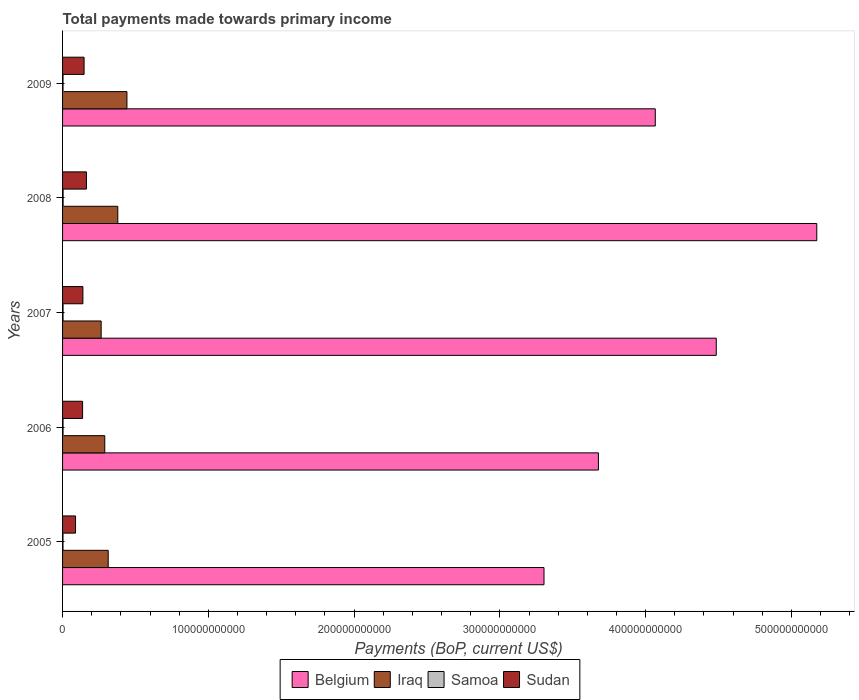What is the total payments made towards primary income in Sudan in 2008?
Offer a very short reply. 1.64e+1. Across all years, what is the maximum total payments made towards primary income in Samoa?
Ensure brevity in your answer.  3.77e+08. Across all years, what is the minimum total payments made towards primary income in Samoa?
Provide a short and direct response. 3.00e+08. In which year was the total payments made towards primary income in Belgium maximum?
Provide a short and direct response. 2008. In which year was the total payments made towards primary income in Iraq minimum?
Provide a short and direct response. 2007. What is the total total payments made towards primary income in Iraq in the graph?
Give a very brief answer. 1.69e+11. What is the difference between the total payments made towards primary income in Samoa in 2005 and that in 2008?
Offer a terse response. -7.67e+07. What is the difference between the total payments made towards primary income in Sudan in 2009 and the total payments made towards primary income in Belgium in 2008?
Your answer should be very brief. -5.03e+11. What is the average total payments made towards primary income in Iraq per year?
Provide a succinct answer. 3.38e+1. In the year 2009, what is the difference between the total payments made towards primary income in Sudan and total payments made towards primary income in Belgium?
Your answer should be compact. -3.92e+11. What is the ratio of the total payments made towards primary income in Sudan in 2005 to that in 2007?
Make the answer very short. 0.64. What is the difference between the highest and the second highest total payments made towards primary income in Belgium?
Provide a short and direct response. 6.90e+1. What is the difference between the highest and the lowest total payments made towards primary income in Samoa?
Your answer should be very brief. 7.67e+07. Is the sum of the total payments made towards primary income in Samoa in 2007 and 2008 greater than the maximum total payments made towards primary income in Iraq across all years?
Keep it short and to the point. No. Is it the case that in every year, the sum of the total payments made towards primary income in Sudan and total payments made towards primary income in Belgium is greater than the sum of total payments made towards primary income in Samoa and total payments made towards primary income in Iraq?
Offer a terse response. No. What does the 1st bar from the top in 2007 represents?
Ensure brevity in your answer.  Sudan. What does the 3rd bar from the bottom in 2008 represents?
Your answer should be compact. Samoa. How many bars are there?
Offer a very short reply. 20. How many years are there in the graph?
Your answer should be compact. 5. What is the difference between two consecutive major ticks on the X-axis?
Ensure brevity in your answer.  1.00e+11. Does the graph contain grids?
Your response must be concise. No. Where does the legend appear in the graph?
Give a very brief answer. Bottom center. How many legend labels are there?
Offer a terse response. 4. How are the legend labels stacked?
Your answer should be compact. Horizontal. What is the title of the graph?
Offer a very short reply. Total payments made towards primary income. What is the label or title of the X-axis?
Provide a succinct answer. Payments (BoP, current US$). What is the label or title of the Y-axis?
Provide a short and direct response. Years. What is the Payments (BoP, current US$) in Belgium in 2005?
Ensure brevity in your answer.  3.30e+11. What is the Payments (BoP, current US$) in Iraq in 2005?
Offer a terse response. 3.13e+1. What is the Payments (BoP, current US$) in Samoa in 2005?
Your answer should be very brief. 3.00e+08. What is the Payments (BoP, current US$) of Sudan in 2005?
Provide a short and direct response. 8.90e+09. What is the Payments (BoP, current US$) of Belgium in 2006?
Provide a short and direct response. 3.68e+11. What is the Payments (BoP, current US$) of Iraq in 2006?
Your answer should be compact. 2.89e+1. What is the Payments (BoP, current US$) in Samoa in 2006?
Provide a short and direct response. 3.29e+08. What is the Payments (BoP, current US$) in Sudan in 2006?
Keep it short and to the point. 1.37e+1. What is the Payments (BoP, current US$) in Belgium in 2007?
Make the answer very short. 4.48e+11. What is the Payments (BoP, current US$) in Iraq in 2007?
Provide a succinct answer. 2.65e+1. What is the Payments (BoP, current US$) in Samoa in 2007?
Your answer should be compact. 3.44e+08. What is the Payments (BoP, current US$) of Sudan in 2007?
Your answer should be compact. 1.40e+1. What is the Payments (BoP, current US$) of Belgium in 2008?
Your response must be concise. 5.17e+11. What is the Payments (BoP, current US$) in Iraq in 2008?
Your response must be concise. 3.79e+1. What is the Payments (BoP, current US$) in Samoa in 2008?
Your answer should be compact. 3.77e+08. What is the Payments (BoP, current US$) in Sudan in 2008?
Give a very brief answer. 1.64e+1. What is the Payments (BoP, current US$) of Belgium in 2009?
Your response must be concise. 4.07e+11. What is the Payments (BoP, current US$) of Iraq in 2009?
Offer a terse response. 4.42e+1. What is the Payments (BoP, current US$) of Samoa in 2009?
Your answer should be very brief. 3.20e+08. What is the Payments (BoP, current US$) in Sudan in 2009?
Make the answer very short. 1.48e+1. Across all years, what is the maximum Payments (BoP, current US$) in Belgium?
Ensure brevity in your answer.  5.17e+11. Across all years, what is the maximum Payments (BoP, current US$) in Iraq?
Provide a succinct answer. 4.42e+1. Across all years, what is the maximum Payments (BoP, current US$) of Samoa?
Your response must be concise. 3.77e+08. Across all years, what is the maximum Payments (BoP, current US$) in Sudan?
Provide a short and direct response. 1.64e+1. Across all years, what is the minimum Payments (BoP, current US$) of Belgium?
Provide a succinct answer. 3.30e+11. Across all years, what is the minimum Payments (BoP, current US$) of Iraq?
Your answer should be compact. 2.65e+1. Across all years, what is the minimum Payments (BoP, current US$) of Samoa?
Offer a terse response. 3.00e+08. Across all years, what is the minimum Payments (BoP, current US$) in Sudan?
Offer a very short reply. 8.90e+09. What is the total Payments (BoP, current US$) of Belgium in the graph?
Your answer should be compact. 2.07e+12. What is the total Payments (BoP, current US$) in Iraq in the graph?
Offer a terse response. 1.69e+11. What is the total Payments (BoP, current US$) of Samoa in the graph?
Provide a succinct answer. 1.67e+09. What is the total Payments (BoP, current US$) in Sudan in the graph?
Your answer should be very brief. 6.77e+1. What is the difference between the Payments (BoP, current US$) in Belgium in 2005 and that in 2006?
Offer a very short reply. -3.73e+1. What is the difference between the Payments (BoP, current US$) in Iraq in 2005 and that in 2006?
Provide a succinct answer. 2.36e+09. What is the difference between the Payments (BoP, current US$) of Samoa in 2005 and that in 2006?
Your response must be concise. -2.86e+07. What is the difference between the Payments (BoP, current US$) of Sudan in 2005 and that in 2006?
Ensure brevity in your answer.  -4.84e+09. What is the difference between the Payments (BoP, current US$) of Belgium in 2005 and that in 2007?
Provide a succinct answer. -1.18e+11. What is the difference between the Payments (BoP, current US$) of Iraq in 2005 and that in 2007?
Provide a succinct answer. 4.83e+09. What is the difference between the Payments (BoP, current US$) of Samoa in 2005 and that in 2007?
Offer a very short reply. -4.42e+07. What is the difference between the Payments (BoP, current US$) of Sudan in 2005 and that in 2007?
Ensure brevity in your answer.  -5.05e+09. What is the difference between the Payments (BoP, current US$) in Belgium in 2005 and that in 2008?
Offer a terse response. -1.87e+11. What is the difference between the Payments (BoP, current US$) in Iraq in 2005 and that in 2008?
Offer a terse response. -6.58e+09. What is the difference between the Payments (BoP, current US$) in Samoa in 2005 and that in 2008?
Ensure brevity in your answer.  -7.67e+07. What is the difference between the Payments (BoP, current US$) in Sudan in 2005 and that in 2008?
Your answer should be very brief. -7.49e+09. What is the difference between the Payments (BoP, current US$) of Belgium in 2005 and that in 2009?
Keep it short and to the point. -7.63e+1. What is the difference between the Payments (BoP, current US$) of Iraq in 2005 and that in 2009?
Make the answer very short. -1.29e+1. What is the difference between the Payments (BoP, current US$) of Samoa in 2005 and that in 2009?
Offer a very short reply. -1.96e+07. What is the difference between the Payments (BoP, current US$) of Sudan in 2005 and that in 2009?
Provide a succinct answer. -5.86e+09. What is the difference between the Payments (BoP, current US$) of Belgium in 2006 and that in 2007?
Offer a terse response. -8.08e+1. What is the difference between the Payments (BoP, current US$) in Iraq in 2006 and that in 2007?
Provide a succinct answer. 2.47e+09. What is the difference between the Payments (BoP, current US$) of Samoa in 2006 and that in 2007?
Your answer should be compact. -1.56e+07. What is the difference between the Payments (BoP, current US$) of Sudan in 2006 and that in 2007?
Provide a short and direct response. -2.10e+08. What is the difference between the Payments (BoP, current US$) of Belgium in 2006 and that in 2008?
Keep it short and to the point. -1.50e+11. What is the difference between the Payments (BoP, current US$) in Iraq in 2006 and that in 2008?
Offer a very short reply. -8.94e+09. What is the difference between the Payments (BoP, current US$) in Samoa in 2006 and that in 2008?
Give a very brief answer. -4.81e+07. What is the difference between the Payments (BoP, current US$) in Sudan in 2006 and that in 2008?
Provide a succinct answer. -2.64e+09. What is the difference between the Payments (BoP, current US$) of Belgium in 2006 and that in 2009?
Ensure brevity in your answer.  -3.90e+1. What is the difference between the Payments (BoP, current US$) in Iraq in 2006 and that in 2009?
Ensure brevity in your answer.  -1.52e+1. What is the difference between the Payments (BoP, current US$) of Samoa in 2006 and that in 2009?
Your answer should be compact. 8.97e+06. What is the difference between the Payments (BoP, current US$) in Sudan in 2006 and that in 2009?
Give a very brief answer. -1.02e+09. What is the difference between the Payments (BoP, current US$) of Belgium in 2007 and that in 2008?
Keep it short and to the point. -6.90e+1. What is the difference between the Payments (BoP, current US$) in Iraq in 2007 and that in 2008?
Give a very brief answer. -1.14e+1. What is the difference between the Payments (BoP, current US$) in Samoa in 2007 and that in 2008?
Ensure brevity in your answer.  -3.25e+07. What is the difference between the Payments (BoP, current US$) of Sudan in 2007 and that in 2008?
Offer a terse response. -2.43e+09. What is the difference between the Payments (BoP, current US$) of Belgium in 2007 and that in 2009?
Offer a terse response. 4.18e+1. What is the difference between the Payments (BoP, current US$) of Iraq in 2007 and that in 2009?
Provide a succinct answer. -1.77e+1. What is the difference between the Payments (BoP, current US$) in Samoa in 2007 and that in 2009?
Your response must be concise. 2.46e+07. What is the difference between the Payments (BoP, current US$) in Sudan in 2007 and that in 2009?
Offer a very short reply. -8.09e+08. What is the difference between the Payments (BoP, current US$) of Belgium in 2008 and that in 2009?
Your answer should be very brief. 1.11e+11. What is the difference between the Payments (BoP, current US$) of Iraq in 2008 and that in 2009?
Make the answer very short. -6.28e+09. What is the difference between the Payments (BoP, current US$) of Samoa in 2008 and that in 2009?
Your answer should be compact. 5.70e+07. What is the difference between the Payments (BoP, current US$) of Sudan in 2008 and that in 2009?
Your response must be concise. 1.62e+09. What is the difference between the Payments (BoP, current US$) in Belgium in 2005 and the Payments (BoP, current US$) in Iraq in 2006?
Your response must be concise. 3.01e+11. What is the difference between the Payments (BoP, current US$) of Belgium in 2005 and the Payments (BoP, current US$) of Samoa in 2006?
Your response must be concise. 3.30e+11. What is the difference between the Payments (BoP, current US$) in Belgium in 2005 and the Payments (BoP, current US$) in Sudan in 2006?
Your answer should be very brief. 3.17e+11. What is the difference between the Payments (BoP, current US$) of Iraq in 2005 and the Payments (BoP, current US$) of Samoa in 2006?
Your answer should be compact. 3.10e+1. What is the difference between the Payments (BoP, current US$) of Iraq in 2005 and the Payments (BoP, current US$) of Sudan in 2006?
Offer a terse response. 1.76e+1. What is the difference between the Payments (BoP, current US$) in Samoa in 2005 and the Payments (BoP, current US$) in Sudan in 2006?
Ensure brevity in your answer.  -1.34e+1. What is the difference between the Payments (BoP, current US$) of Belgium in 2005 and the Payments (BoP, current US$) of Iraq in 2007?
Ensure brevity in your answer.  3.04e+11. What is the difference between the Payments (BoP, current US$) of Belgium in 2005 and the Payments (BoP, current US$) of Samoa in 2007?
Provide a short and direct response. 3.30e+11. What is the difference between the Payments (BoP, current US$) in Belgium in 2005 and the Payments (BoP, current US$) in Sudan in 2007?
Your answer should be very brief. 3.16e+11. What is the difference between the Payments (BoP, current US$) of Iraq in 2005 and the Payments (BoP, current US$) of Samoa in 2007?
Make the answer very short. 3.10e+1. What is the difference between the Payments (BoP, current US$) in Iraq in 2005 and the Payments (BoP, current US$) in Sudan in 2007?
Offer a terse response. 1.74e+1. What is the difference between the Payments (BoP, current US$) of Samoa in 2005 and the Payments (BoP, current US$) of Sudan in 2007?
Ensure brevity in your answer.  -1.37e+1. What is the difference between the Payments (BoP, current US$) of Belgium in 2005 and the Payments (BoP, current US$) of Iraq in 2008?
Provide a succinct answer. 2.92e+11. What is the difference between the Payments (BoP, current US$) in Belgium in 2005 and the Payments (BoP, current US$) in Samoa in 2008?
Your response must be concise. 3.30e+11. What is the difference between the Payments (BoP, current US$) of Belgium in 2005 and the Payments (BoP, current US$) of Sudan in 2008?
Make the answer very short. 3.14e+11. What is the difference between the Payments (BoP, current US$) in Iraq in 2005 and the Payments (BoP, current US$) in Samoa in 2008?
Offer a very short reply. 3.09e+1. What is the difference between the Payments (BoP, current US$) in Iraq in 2005 and the Payments (BoP, current US$) in Sudan in 2008?
Your answer should be very brief. 1.49e+1. What is the difference between the Payments (BoP, current US$) in Samoa in 2005 and the Payments (BoP, current US$) in Sudan in 2008?
Keep it short and to the point. -1.61e+1. What is the difference between the Payments (BoP, current US$) of Belgium in 2005 and the Payments (BoP, current US$) of Iraq in 2009?
Provide a succinct answer. 2.86e+11. What is the difference between the Payments (BoP, current US$) of Belgium in 2005 and the Payments (BoP, current US$) of Samoa in 2009?
Your answer should be very brief. 3.30e+11. What is the difference between the Payments (BoP, current US$) in Belgium in 2005 and the Payments (BoP, current US$) in Sudan in 2009?
Ensure brevity in your answer.  3.16e+11. What is the difference between the Payments (BoP, current US$) of Iraq in 2005 and the Payments (BoP, current US$) of Samoa in 2009?
Your answer should be very brief. 3.10e+1. What is the difference between the Payments (BoP, current US$) of Iraq in 2005 and the Payments (BoP, current US$) of Sudan in 2009?
Your answer should be very brief. 1.65e+1. What is the difference between the Payments (BoP, current US$) in Samoa in 2005 and the Payments (BoP, current US$) in Sudan in 2009?
Your answer should be very brief. -1.45e+1. What is the difference between the Payments (BoP, current US$) of Belgium in 2006 and the Payments (BoP, current US$) of Iraq in 2007?
Offer a terse response. 3.41e+11. What is the difference between the Payments (BoP, current US$) of Belgium in 2006 and the Payments (BoP, current US$) of Samoa in 2007?
Offer a very short reply. 3.67e+11. What is the difference between the Payments (BoP, current US$) of Belgium in 2006 and the Payments (BoP, current US$) of Sudan in 2007?
Offer a very short reply. 3.54e+11. What is the difference between the Payments (BoP, current US$) of Iraq in 2006 and the Payments (BoP, current US$) of Samoa in 2007?
Provide a short and direct response. 2.86e+1. What is the difference between the Payments (BoP, current US$) in Iraq in 2006 and the Payments (BoP, current US$) in Sudan in 2007?
Give a very brief answer. 1.50e+1. What is the difference between the Payments (BoP, current US$) in Samoa in 2006 and the Payments (BoP, current US$) in Sudan in 2007?
Provide a short and direct response. -1.36e+1. What is the difference between the Payments (BoP, current US$) in Belgium in 2006 and the Payments (BoP, current US$) in Iraq in 2008?
Provide a succinct answer. 3.30e+11. What is the difference between the Payments (BoP, current US$) of Belgium in 2006 and the Payments (BoP, current US$) of Samoa in 2008?
Provide a succinct answer. 3.67e+11. What is the difference between the Payments (BoP, current US$) in Belgium in 2006 and the Payments (BoP, current US$) in Sudan in 2008?
Give a very brief answer. 3.51e+11. What is the difference between the Payments (BoP, current US$) of Iraq in 2006 and the Payments (BoP, current US$) of Samoa in 2008?
Provide a succinct answer. 2.86e+1. What is the difference between the Payments (BoP, current US$) in Iraq in 2006 and the Payments (BoP, current US$) in Sudan in 2008?
Make the answer very short. 1.26e+1. What is the difference between the Payments (BoP, current US$) of Samoa in 2006 and the Payments (BoP, current US$) of Sudan in 2008?
Keep it short and to the point. -1.61e+1. What is the difference between the Payments (BoP, current US$) of Belgium in 2006 and the Payments (BoP, current US$) of Iraq in 2009?
Make the answer very short. 3.23e+11. What is the difference between the Payments (BoP, current US$) of Belgium in 2006 and the Payments (BoP, current US$) of Samoa in 2009?
Make the answer very short. 3.67e+11. What is the difference between the Payments (BoP, current US$) of Belgium in 2006 and the Payments (BoP, current US$) of Sudan in 2009?
Provide a succinct answer. 3.53e+11. What is the difference between the Payments (BoP, current US$) of Iraq in 2006 and the Payments (BoP, current US$) of Samoa in 2009?
Your response must be concise. 2.86e+1. What is the difference between the Payments (BoP, current US$) in Iraq in 2006 and the Payments (BoP, current US$) in Sudan in 2009?
Make the answer very short. 1.42e+1. What is the difference between the Payments (BoP, current US$) of Samoa in 2006 and the Payments (BoP, current US$) of Sudan in 2009?
Make the answer very short. -1.44e+1. What is the difference between the Payments (BoP, current US$) in Belgium in 2007 and the Payments (BoP, current US$) in Iraq in 2008?
Offer a very short reply. 4.11e+11. What is the difference between the Payments (BoP, current US$) in Belgium in 2007 and the Payments (BoP, current US$) in Samoa in 2008?
Provide a succinct answer. 4.48e+11. What is the difference between the Payments (BoP, current US$) of Belgium in 2007 and the Payments (BoP, current US$) of Sudan in 2008?
Provide a short and direct response. 4.32e+11. What is the difference between the Payments (BoP, current US$) in Iraq in 2007 and the Payments (BoP, current US$) in Samoa in 2008?
Keep it short and to the point. 2.61e+1. What is the difference between the Payments (BoP, current US$) of Iraq in 2007 and the Payments (BoP, current US$) of Sudan in 2008?
Your answer should be very brief. 1.01e+1. What is the difference between the Payments (BoP, current US$) of Samoa in 2007 and the Payments (BoP, current US$) of Sudan in 2008?
Your answer should be very brief. -1.60e+1. What is the difference between the Payments (BoP, current US$) of Belgium in 2007 and the Payments (BoP, current US$) of Iraq in 2009?
Your answer should be compact. 4.04e+11. What is the difference between the Payments (BoP, current US$) in Belgium in 2007 and the Payments (BoP, current US$) in Samoa in 2009?
Provide a succinct answer. 4.48e+11. What is the difference between the Payments (BoP, current US$) of Belgium in 2007 and the Payments (BoP, current US$) of Sudan in 2009?
Provide a short and direct response. 4.34e+11. What is the difference between the Payments (BoP, current US$) of Iraq in 2007 and the Payments (BoP, current US$) of Samoa in 2009?
Provide a short and direct response. 2.62e+1. What is the difference between the Payments (BoP, current US$) in Iraq in 2007 and the Payments (BoP, current US$) in Sudan in 2009?
Ensure brevity in your answer.  1.17e+1. What is the difference between the Payments (BoP, current US$) of Samoa in 2007 and the Payments (BoP, current US$) of Sudan in 2009?
Your response must be concise. -1.44e+1. What is the difference between the Payments (BoP, current US$) of Belgium in 2008 and the Payments (BoP, current US$) of Iraq in 2009?
Keep it short and to the point. 4.73e+11. What is the difference between the Payments (BoP, current US$) of Belgium in 2008 and the Payments (BoP, current US$) of Samoa in 2009?
Your answer should be very brief. 5.17e+11. What is the difference between the Payments (BoP, current US$) in Belgium in 2008 and the Payments (BoP, current US$) in Sudan in 2009?
Offer a very short reply. 5.03e+11. What is the difference between the Payments (BoP, current US$) in Iraq in 2008 and the Payments (BoP, current US$) in Samoa in 2009?
Your response must be concise. 3.76e+1. What is the difference between the Payments (BoP, current US$) of Iraq in 2008 and the Payments (BoP, current US$) of Sudan in 2009?
Offer a very short reply. 2.31e+1. What is the difference between the Payments (BoP, current US$) of Samoa in 2008 and the Payments (BoP, current US$) of Sudan in 2009?
Keep it short and to the point. -1.44e+1. What is the average Payments (BoP, current US$) in Belgium per year?
Offer a very short reply. 4.14e+11. What is the average Payments (BoP, current US$) of Iraq per year?
Your answer should be very brief. 3.38e+1. What is the average Payments (BoP, current US$) of Samoa per year?
Provide a short and direct response. 3.34e+08. What is the average Payments (BoP, current US$) in Sudan per year?
Keep it short and to the point. 1.35e+1. In the year 2005, what is the difference between the Payments (BoP, current US$) in Belgium and Payments (BoP, current US$) in Iraq?
Your response must be concise. 2.99e+11. In the year 2005, what is the difference between the Payments (BoP, current US$) of Belgium and Payments (BoP, current US$) of Samoa?
Make the answer very short. 3.30e+11. In the year 2005, what is the difference between the Payments (BoP, current US$) in Belgium and Payments (BoP, current US$) in Sudan?
Provide a short and direct response. 3.21e+11. In the year 2005, what is the difference between the Payments (BoP, current US$) of Iraq and Payments (BoP, current US$) of Samoa?
Make the answer very short. 3.10e+1. In the year 2005, what is the difference between the Payments (BoP, current US$) in Iraq and Payments (BoP, current US$) in Sudan?
Provide a short and direct response. 2.24e+1. In the year 2005, what is the difference between the Payments (BoP, current US$) in Samoa and Payments (BoP, current US$) in Sudan?
Offer a very short reply. -8.60e+09. In the year 2006, what is the difference between the Payments (BoP, current US$) of Belgium and Payments (BoP, current US$) of Iraq?
Keep it short and to the point. 3.39e+11. In the year 2006, what is the difference between the Payments (BoP, current US$) in Belgium and Payments (BoP, current US$) in Samoa?
Your response must be concise. 3.67e+11. In the year 2006, what is the difference between the Payments (BoP, current US$) of Belgium and Payments (BoP, current US$) of Sudan?
Your answer should be compact. 3.54e+11. In the year 2006, what is the difference between the Payments (BoP, current US$) of Iraq and Payments (BoP, current US$) of Samoa?
Ensure brevity in your answer.  2.86e+1. In the year 2006, what is the difference between the Payments (BoP, current US$) in Iraq and Payments (BoP, current US$) in Sudan?
Offer a terse response. 1.52e+1. In the year 2006, what is the difference between the Payments (BoP, current US$) of Samoa and Payments (BoP, current US$) of Sudan?
Provide a short and direct response. -1.34e+1. In the year 2007, what is the difference between the Payments (BoP, current US$) of Belgium and Payments (BoP, current US$) of Iraq?
Give a very brief answer. 4.22e+11. In the year 2007, what is the difference between the Payments (BoP, current US$) in Belgium and Payments (BoP, current US$) in Samoa?
Provide a succinct answer. 4.48e+11. In the year 2007, what is the difference between the Payments (BoP, current US$) in Belgium and Payments (BoP, current US$) in Sudan?
Your answer should be very brief. 4.35e+11. In the year 2007, what is the difference between the Payments (BoP, current US$) in Iraq and Payments (BoP, current US$) in Samoa?
Provide a short and direct response. 2.61e+1. In the year 2007, what is the difference between the Payments (BoP, current US$) of Iraq and Payments (BoP, current US$) of Sudan?
Provide a succinct answer. 1.25e+1. In the year 2007, what is the difference between the Payments (BoP, current US$) of Samoa and Payments (BoP, current US$) of Sudan?
Offer a terse response. -1.36e+1. In the year 2008, what is the difference between the Payments (BoP, current US$) in Belgium and Payments (BoP, current US$) in Iraq?
Your answer should be very brief. 4.80e+11. In the year 2008, what is the difference between the Payments (BoP, current US$) in Belgium and Payments (BoP, current US$) in Samoa?
Ensure brevity in your answer.  5.17e+11. In the year 2008, what is the difference between the Payments (BoP, current US$) of Belgium and Payments (BoP, current US$) of Sudan?
Your answer should be compact. 5.01e+11. In the year 2008, what is the difference between the Payments (BoP, current US$) of Iraq and Payments (BoP, current US$) of Samoa?
Your response must be concise. 3.75e+1. In the year 2008, what is the difference between the Payments (BoP, current US$) in Iraq and Payments (BoP, current US$) in Sudan?
Offer a terse response. 2.15e+1. In the year 2008, what is the difference between the Payments (BoP, current US$) in Samoa and Payments (BoP, current US$) in Sudan?
Keep it short and to the point. -1.60e+1. In the year 2009, what is the difference between the Payments (BoP, current US$) of Belgium and Payments (BoP, current US$) of Iraq?
Give a very brief answer. 3.62e+11. In the year 2009, what is the difference between the Payments (BoP, current US$) of Belgium and Payments (BoP, current US$) of Samoa?
Provide a short and direct response. 4.06e+11. In the year 2009, what is the difference between the Payments (BoP, current US$) of Belgium and Payments (BoP, current US$) of Sudan?
Your answer should be compact. 3.92e+11. In the year 2009, what is the difference between the Payments (BoP, current US$) of Iraq and Payments (BoP, current US$) of Samoa?
Provide a succinct answer. 4.38e+1. In the year 2009, what is the difference between the Payments (BoP, current US$) of Iraq and Payments (BoP, current US$) of Sudan?
Offer a terse response. 2.94e+1. In the year 2009, what is the difference between the Payments (BoP, current US$) in Samoa and Payments (BoP, current US$) in Sudan?
Make the answer very short. -1.44e+1. What is the ratio of the Payments (BoP, current US$) in Belgium in 2005 to that in 2006?
Keep it short and to the point. 0.9. What is the ratio of the Payments (BoP, current US$) in Iraq in 2005 to that in 2006?
Ensure brevity in your answer.  1.08. What is the ratio of the Payments (BoP, current US$) of Samoa in 2005 to that in 2006?
Keep it short and to the point. 0.91. What is the ratio of the Payments (BoP, current US$) of Sudan in 2005 to that in 2006?
Your answer should be very brief. 0.65. What is the ratio of the Payments (BoP, current US$) in Belgium in 2005 to that in 2007?
Make the answer very short. 0.74. What is the ratio of the Payments (BoP, current US$) in Iraq in 2005 to that in 2007?
Ensure brevity in your answer.  1.18. What is the ratio of the Payments (BoP, current US$) in Samoa in 2005 to that in 2007?
Give a very brief answer. 0.87. What is the ratio of the Payments (BoP, current US$) of Sudan in 2005 to that in 2007?
Your answer should be compact. 0.64. What is the ratio of the Payments (BoP, current US$) of Belgium in 2005 to that in 2008?
Your response must be concise. 0.64. What is the ratio of the Payments (BoP, current US$) of Iraq in 2005 to that in 2008?
Keep it short and to the point. 0.83. What is the ratio of the Payments (BoP, current US$) in Samoa in 2005 to that in 2008?
Your answer should be very brief. 0.8. What is the ratio of the Payments (BoP, current US$) of Sudan in 2005 to that in 2008?
Provide a short and direct response. 0.54. What is the ratio of the Payments (BoP, current US$) in Belgium in 2005 to that in 2009?
Give a very brief answer. 0.81. What is the ratio of the Payments (BoP, current US$) of Iraq in 2005 to that in 2009?
Keep it short and to the point. 0.71. What is the ratio of the Payments (BoP, current US$) in Samoa in 2005 to that in 2009?
Your answer should be compact. 0.94. What is the ratio of the Payments (BoP, current US$) of Sudan in 2005 to that in 2009?
Provide a succinct answer. 0.6. What is the ratio of the Payments (BoP, current US$) in Belgium in 2006 to that in 2007?
Ensure brevity in your answer.  0.82. What is the ratio of the Payments (BoP, current US$) in Iraq in 2006 to that in 2007?
Provide a short and direct response. 1.09. What is the ratio of the Payments (BoP, current US$) of Samoa in 2006 to that in 2007?
Make the answer very short. 0.95. What is the ratio of the Payments (BoP, current US$) of Sudan in 2006 to that in 2007?
Ensure brevity in your answer.  0.98. What is the ratio of the Payments (BoP, current US$) of Belgium in 2006 to that in 2008?
Provide a succinct answer. 0.71. What is the ratio of the Payments (BoP, current US$) in Iraq in 2006 to that in 2008?
Provide a succinct answer. 0.76. What is the ratio of the Payments (BoP, current US$) in Samoa in 2006 to that in 2008?
Provide a short and direct response. 0.87. What is the ratio of the Payments (BoP, current US$) in Sudan in 2006 to that in 2008?
Offer a terse response. 0.84. What is the ratio of the Payments (BoP, current US$) of Belgium in 2006 to that in 2009?
Your answer should be very brief. 0.9. What is the ratio of the Payments (BoP, current US$) of Iraq in 2006 to that in 2009?
Provide a succinct answer. 0.66. What is the ratio of the Payments (BoP, current US$) in Samoa in 2006 to that in 2009?
Offer a very short reply. 1.03. What is the ratio of the Payments (BoP, current US$) of Sudan in 2006 to that in 2009?
Provide a short and direct response. 0.93. What is the ratio of the Payments (BoP, current US$) in Belgium in 2007 to that in 2008?
Give a very brief answer. 0.87. What is the ratio of the Payments (BoP, current US$) in Iraq in 2007 to that in 2008?
Provide a short and direct response. 0.7. What is the ratio of the Payments (BoP, current US$) of Samoa in 2007 to that in 2008?
Give a very brief answer. 0.91. What is the ratio of the Payments (BoP, current US$) in Sudan in 2007 to that in 2008?
Make the answer very short. 0.85. What is the ratio of the Payments (BoP, current US$) in Belgium in 2007 to that in 2009?
Your response must be concise. 1.1. What is the ratio of the Payments (BoP, current US$) of Iraq in 2007 to that in 2009?
Give a very brief answer. 0.6. What is the ratio of the Payments (BoP, current US$) of Samoa in 2007 to that in 2009?
Your answer should be very brief. 1.08. What is the ratio of the Payments (BoP, current US$) in Sudan in 2007 to that in 2009?
Give a very brief answer. 0.95. What is the ratio of the Payments (BoP, current US$) in Belgium in 2008 to that in 2009?
Your response must be concise. 1.27. What is the ratio of the Payments (BoP, current US$) in Iraq in 2008 to that in 2009?
Provide a short and direct response. 0.86. What is the ratio of the Payments (BoP, current US$) of Samoa in 2008 to that in 2009?
Give a very brief answer. 1.18. What is the ratio of the Payments (BoP, current US$) in Sudan in 2008 to that in 2009?
Your answer should be very brief. 1.11. What is the difference between the highest and the second highest Payments (BoP, current US$) of Belgium?
Give a very brief answer. 6.90e+1. What is the difference between the highest and the second highest Payments (BoP, current US$) in Iraq?
Offer a very short reply. 6.28e+09. What is the difference between the highest and the second highest Payments (BoP, current US$) of Samoa?
Give a very brief answer. 3.25e+07. What is the difference between the highest and the second highest Payments (BoP, current US$) in Sudan?
Your response must be concise. 1.62e+09. What is the difference between the highest and the lowest Payments (BoP, current US$) of Belgium?
Ensure brevity in your answer.  1.87e+11. What is the difference between the highest and the lowest Payments (BoP, current US$) in Iraq?
Keep it short and to the point. 1.77e+1. What is the difference between the highest and the lowest Payments (BoP, current US$) of Samoa?
Your answer should be compact. 7.67e+07. What is the difference between the highest and the lowest Payments (BoP, current US$) in Sudan?
Your answer should be compact. 7.49e+09. 